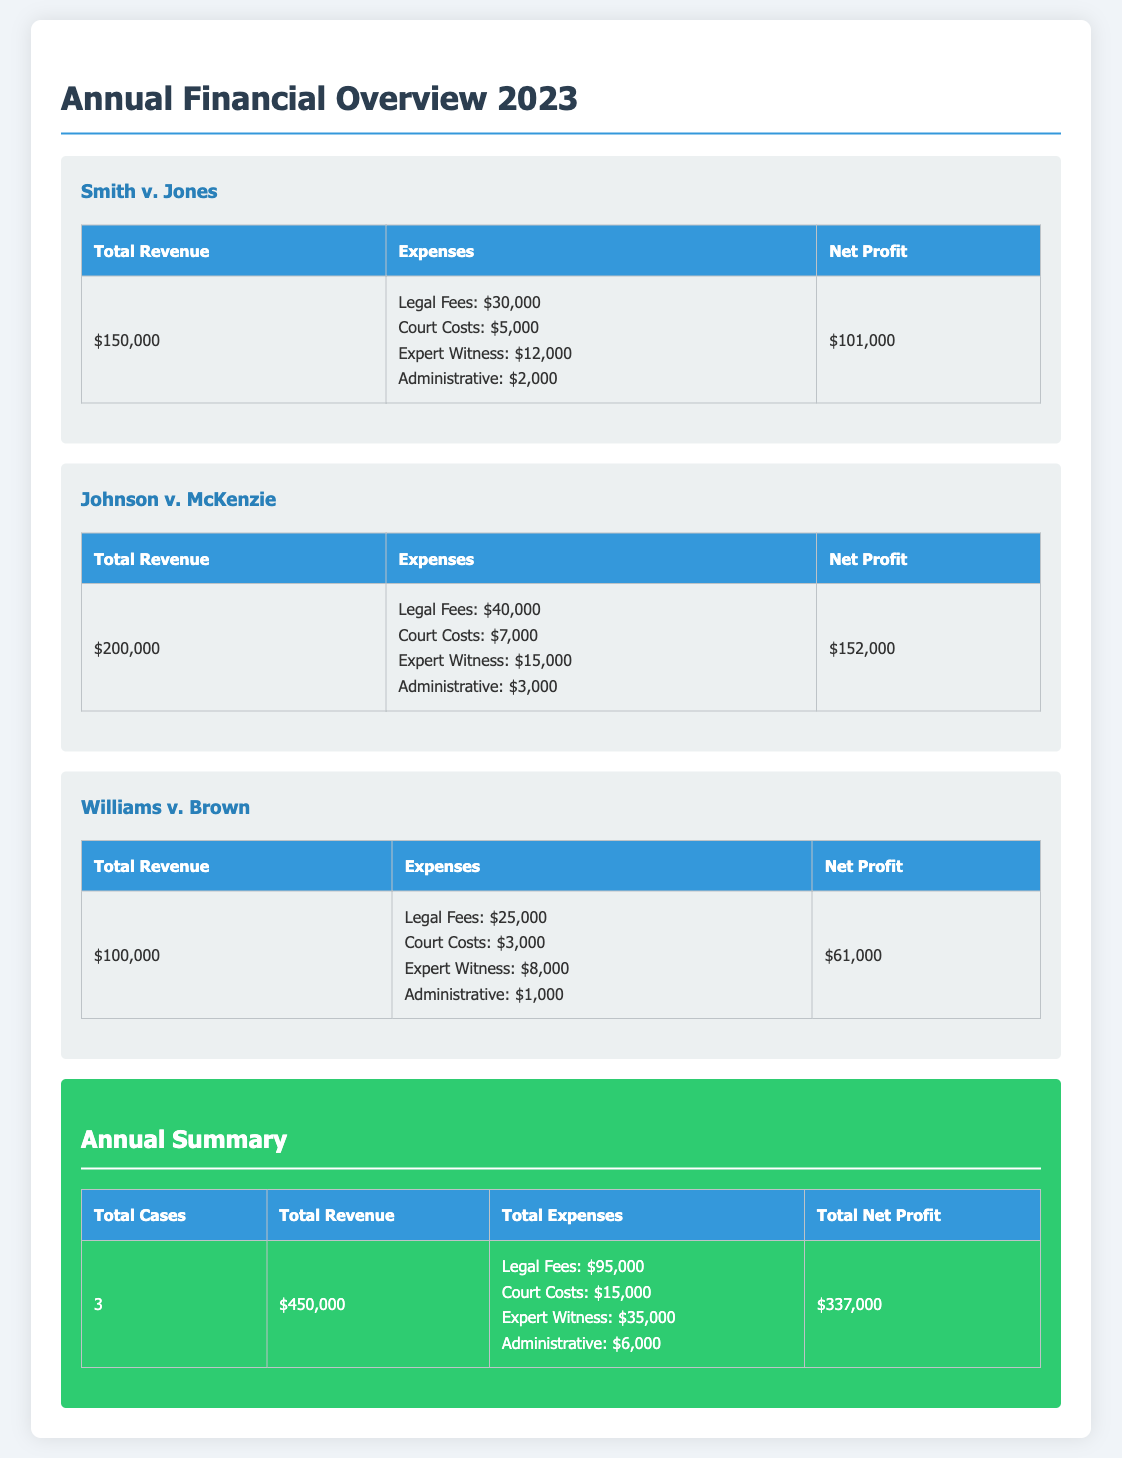What is the total revenue from Smith v. Jones? The total revenue specifically for Smith v. Jones as listed in the document is $150,000.
Answer: $150,000 What is the total expense for Johnson v. McKenzie? The total expenses for Johnson v. McKenzie include several categories, with a cumulative total appearing as part of the breakdown.
Answer: Legal Fees: $40,000; Court Costs: $7,000; Expert Witness: $15,000; Administrative: $3,000 What is the net profit for Williams v. Brown? The net profit is reported in the table and reflects the financial outcome after expenses have been deducted from total revenue.
Answer: $61,000 How many cases are included in the annual summary? The total cases are explicitly stated in the summary section as a part of the overall report.
Answer: 3 What is the total revenue from all cases managed? The total revenue for all cases is summarized in the annual summary table, which aggregates revenue from each case.
Answer: $450,000 Which case had the highest net profit? By comparing the net profits of each case listed, it can be determined which had the most favorable financial outcome.
Answer: Johnson v. McKenzie What are the total legal fees for all cases combined? The combined legal fees can be calculated by adding each case's legal fees together as provided in their respective expense breakdowns.
Answer: $95,000 What is the total net profit for the year? The net profit for the year is presented in the summary table and is calculated by deducting total expenses from total revenue.
Answer: $337,000 What is the court cost listed for Smith v. Jones? The specific court cost for Smith v. Jones is detailed within the expense table relating to that case.
Answer: $5,000 